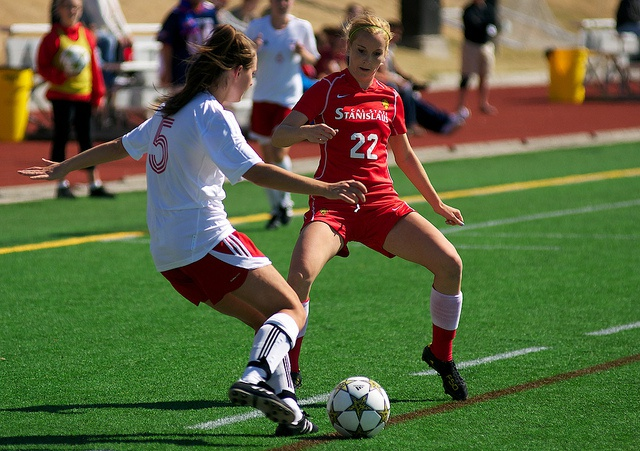Describe the objects in this image and their specific colors. I can see people in tan, black, gray, and white tones, people in tan, maroon, black, brown, and white tones, people in tan, black, maroon, gray, and brown tones, people in tan, gray, black, and lavender tones, and people in tan, black, maroon, and gray tones in this image. 